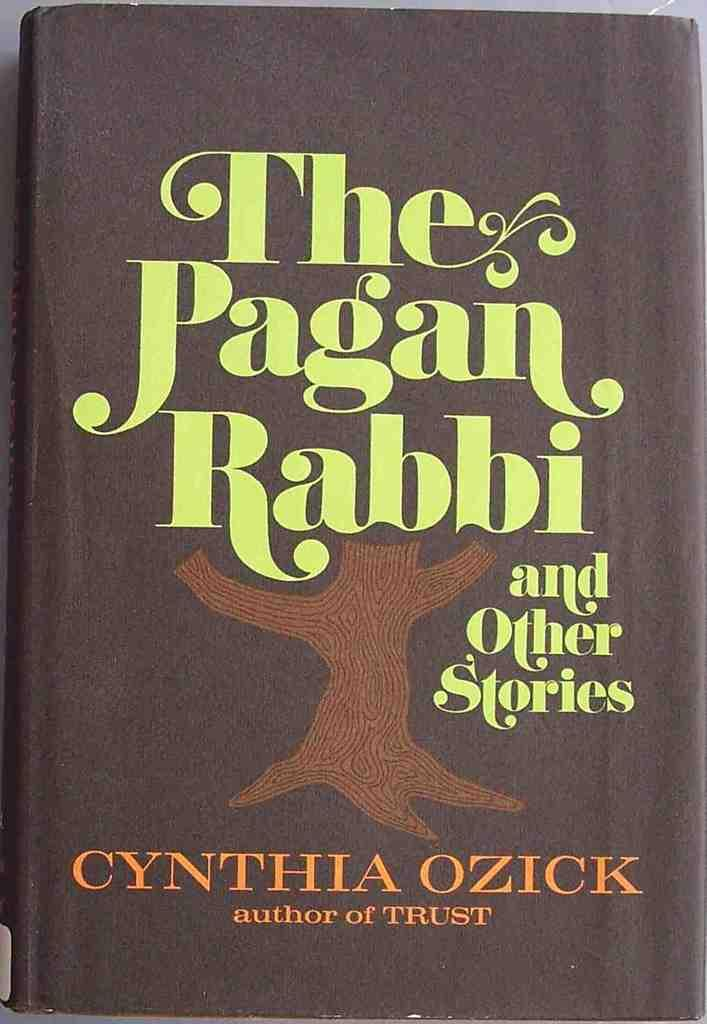<image>
Relay a brief, clear account of the picture shown. A book title the pagan rabbi and other stories 